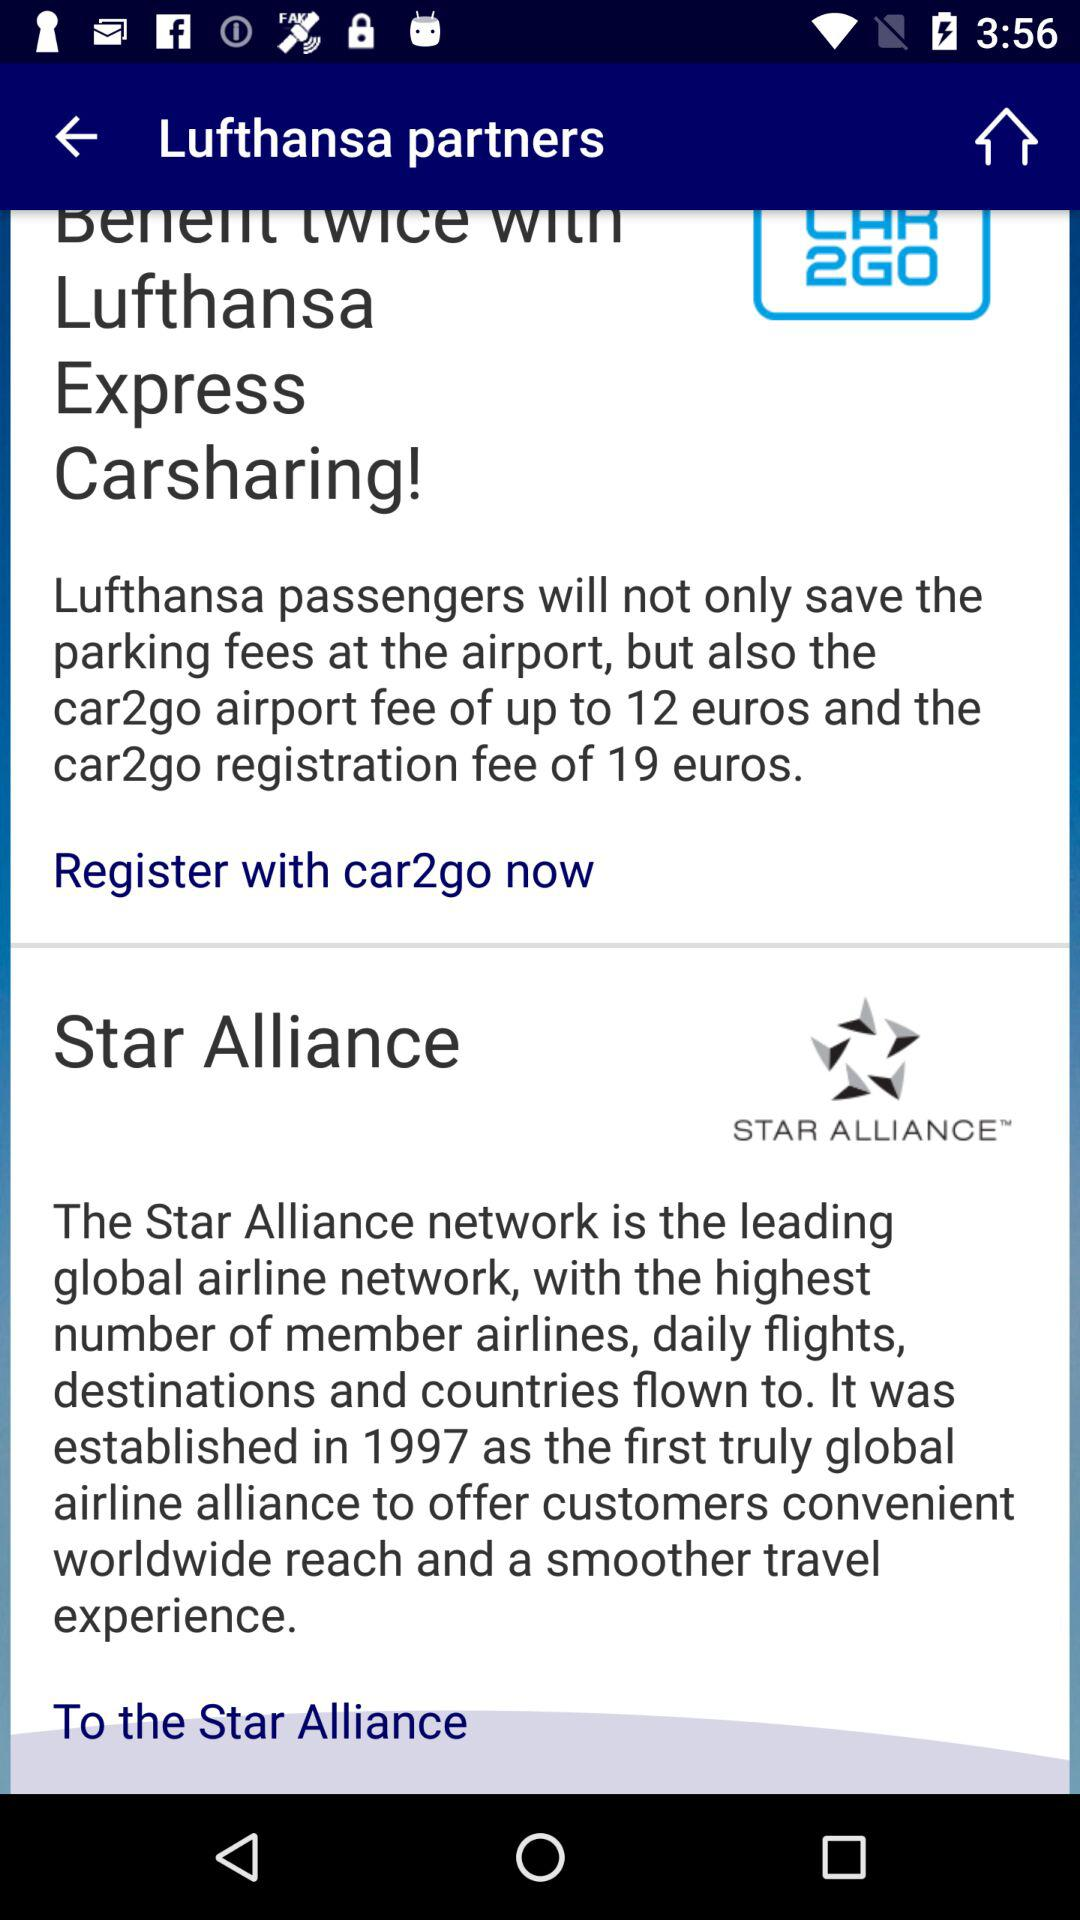How much is the "car2go" registration fee? The "car2go" registration fee is 19 euros. 